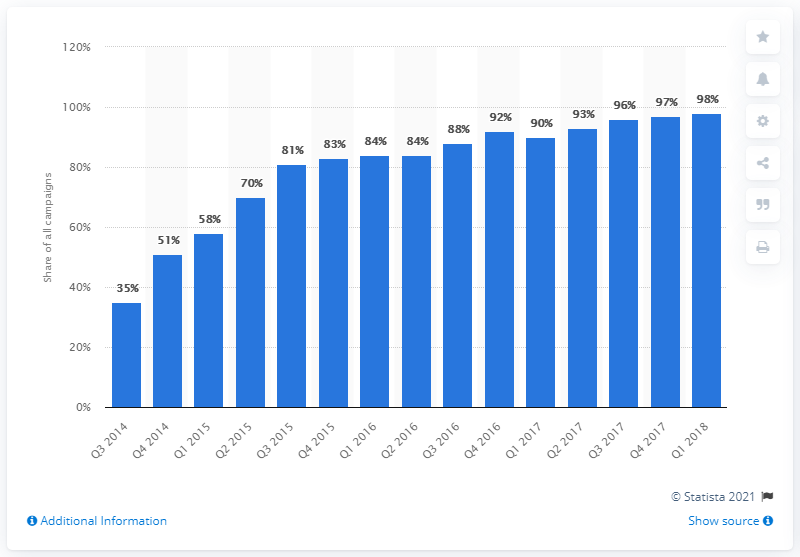List a handful of essential elements in this visual. Nine hundred and eighty percent of digital video ad campaigns in the US during the first quarter of 2018 included cross-screen components. In the US, approximately 90% of digital video ad campaigns included cross screen components a year earlier. 